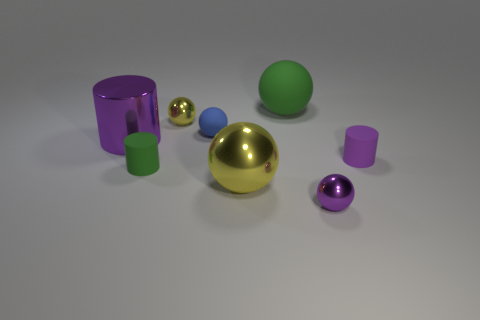The purple cylinder on the right side of the tiny rubber cylinder that is in front of the matte thing that is to the right of the green ball is made of what material?
Keep it short and to the point. Rubber. What number of objects are either yellow metal balls or metallic balls?
Offer a terse response. 3. The tiny yellow metallic thing has what shape?
Your answer should be compact. Sphere. There is a blue rubber object that is behind the tiny metallic ball that is right of the small blue matte object; what shape is it?
Give a very brief answer. Sphere. Are the cylinder that is to the right of the big rubber ball and the tiny green cylinder made of the same material?
Make the answer very short. Yes. How many cyan things are small rubber cylinders or tiny balls?
Offer a very short reply. 0. Is there a object that has the same color as the big rubber ball?
Give a very brief answer. Yes. Are there any blue balls that have the same material as the large green thing?
Offer a terse response. Yes. There is a metallic object that is both behind the tiny purple matte thing and in front of the tiny yellow thing; what is its shape?
Your response must be concise. Cylinder. How many large things are either purple metal things or green cubes?
Offer a very short reply. 1. 